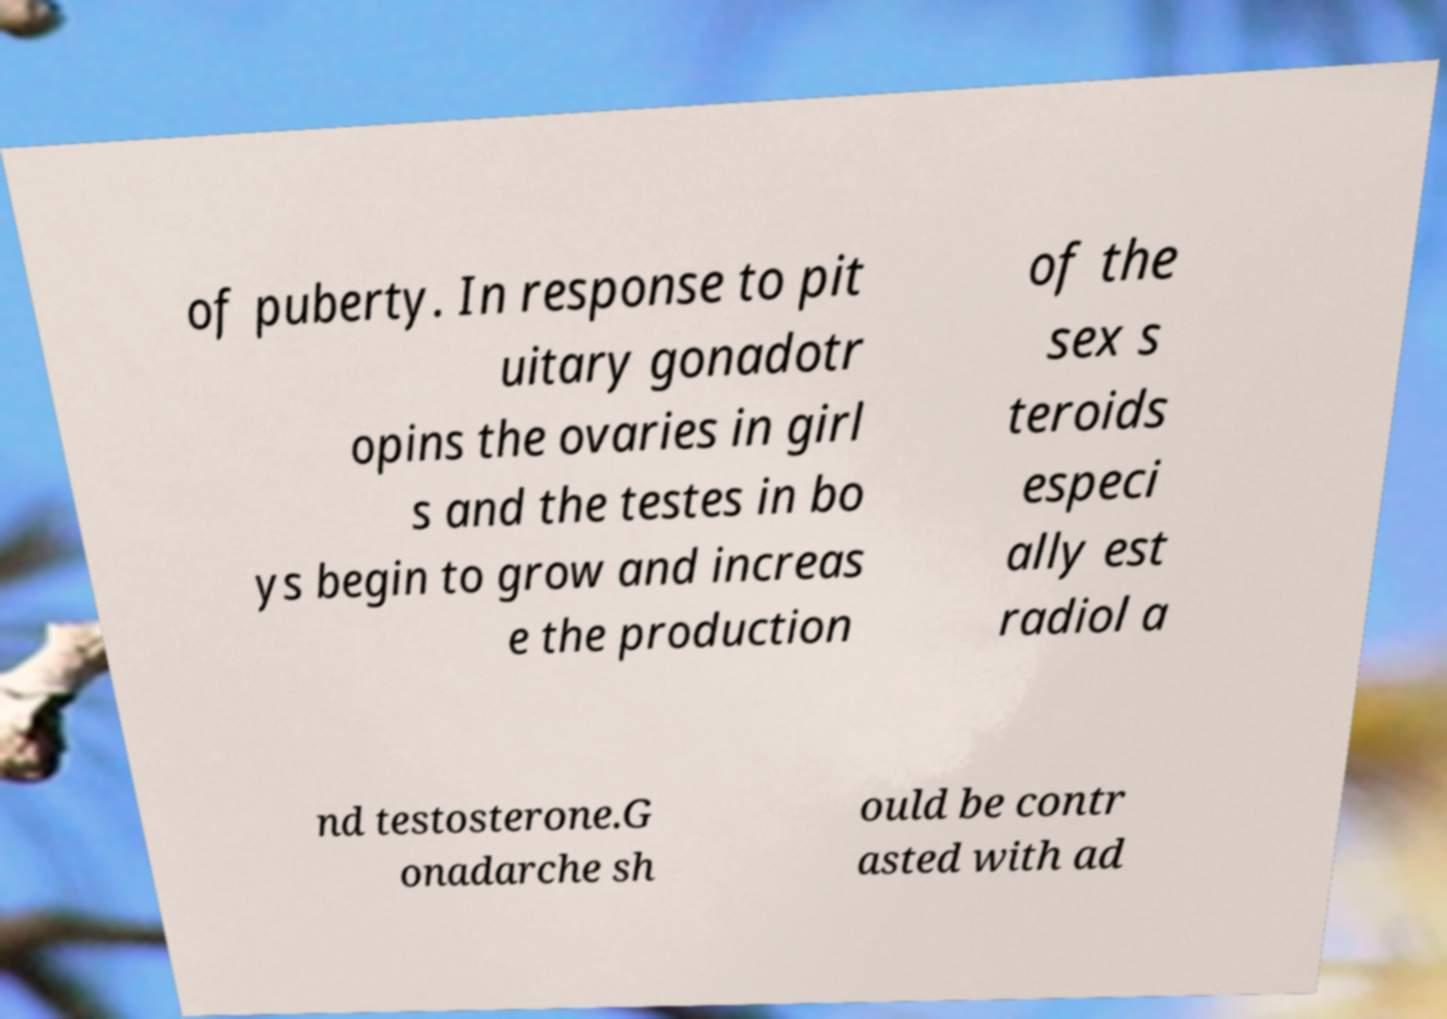Please identify and transcribe the text found in this image. of puberty. In response to pit uitary gonadotr opins the ovaries in girl s and the testes in bo ys begin to grow and increas e the production of the sex s teroids especi ally est radiol a nd testosterone.G onadarche sh ould be contr asted with ad 